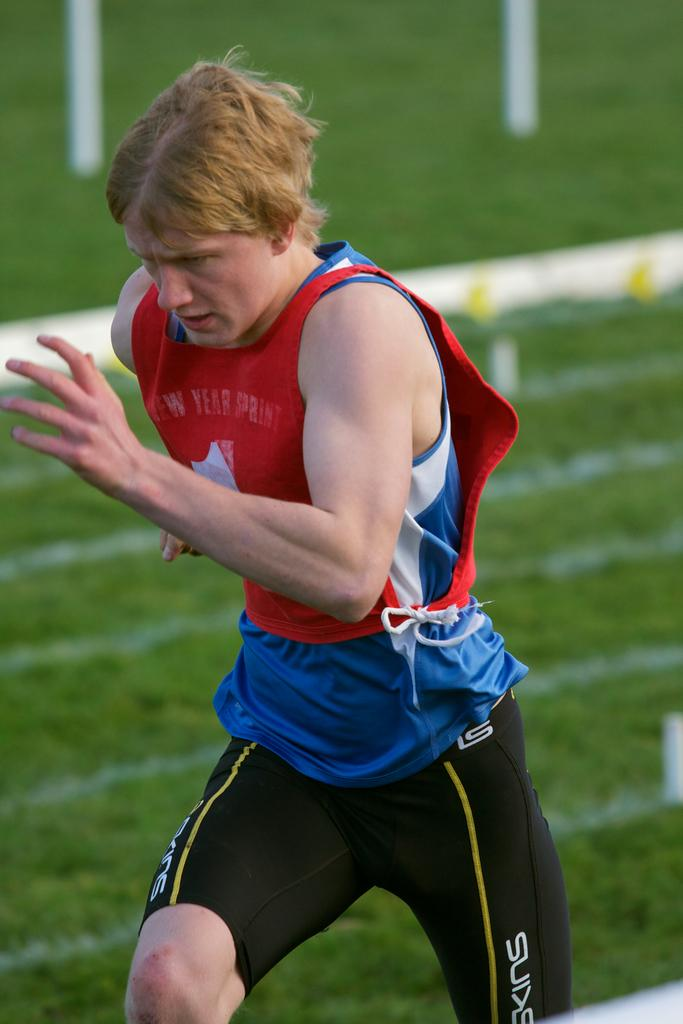<image>
Summarize the visual content of the image. A man runs in a shirt that has the word sprint on it. 